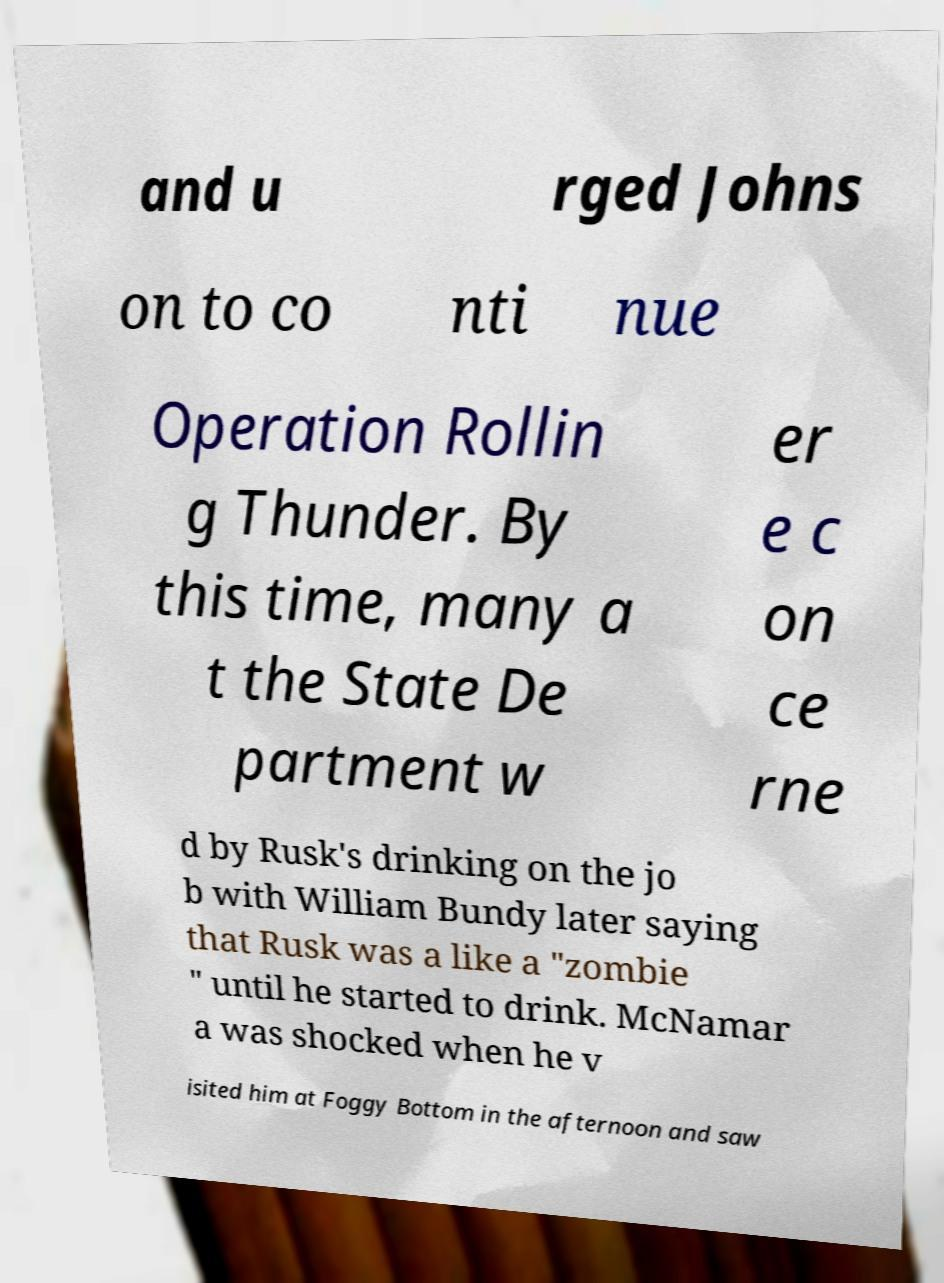There's text embedded in this image that I need extracted. Can you transcribe it verbatim? and u rged Johns on to co nti nue Operation Rollin g Thunder. By this time, many a t the State De partment w er e c on ce rne d by Rusk's drinking on the jo b with William Bundy later saying that Rusk was a like a "zombie " until he started to drink. McNamar a was shocked when he v isited him at Foggy Bottom in the afternoon and saw 